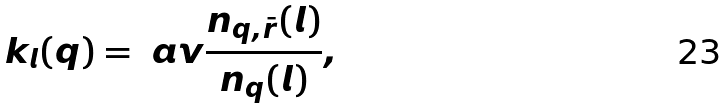<formula> <loc_0><loc_0><loc_500><loc_500>k _ { l } ( q ) = \ a v { \frac { n _ { q , \bar { r } } ( l ) } { n _ { q } ( l ) } } ,</formula> 